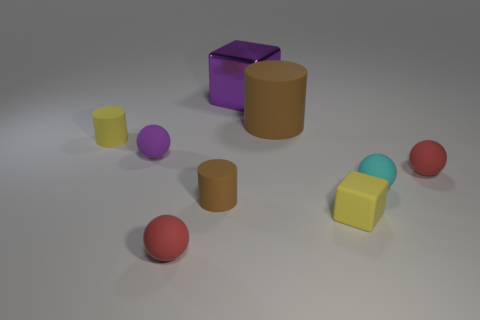There is a yellow rubber thing left of the tiny yellow thing that is on the right side of the red sphere that is in front of the rubber cube; what shape is it?
Keep it short and to the point. Cylinder. How many other things are the same material as the yellow cylinder?
Give a very brief answer. 7. What number of objects are cubes left of the small cyan matte sphere or tiny matte spheres?
Your response must be concise. 6. There is a brown object that is in front of the red sphere behind the small cyan sphere; what is its shape?
Offer a terse response. Cylinder. Does the small red rubber thing on the right side of the cyan rubber thing have the same shape as the tiny purple matte object?
Keep it short and to the point. Yes. What is the color of the block that is to the right of the large rubber cylinder?
Your answer should be very brief. Yellow. How many spheres are tiny yellow objects or big brown things?
Provide a short and direct response. 0. What is the size of the cyan ball on the right side of the brown matte thing behind the tiny purple thing?
Offer a terse response. Small. Does the large matte thing have the same color as the cylinder that is in front of the small cyan matte object?
Offer a very short reply. Yes. There is a cyan ball; what number of purple matte things are in front of it?
Make the answer very short. 0. 